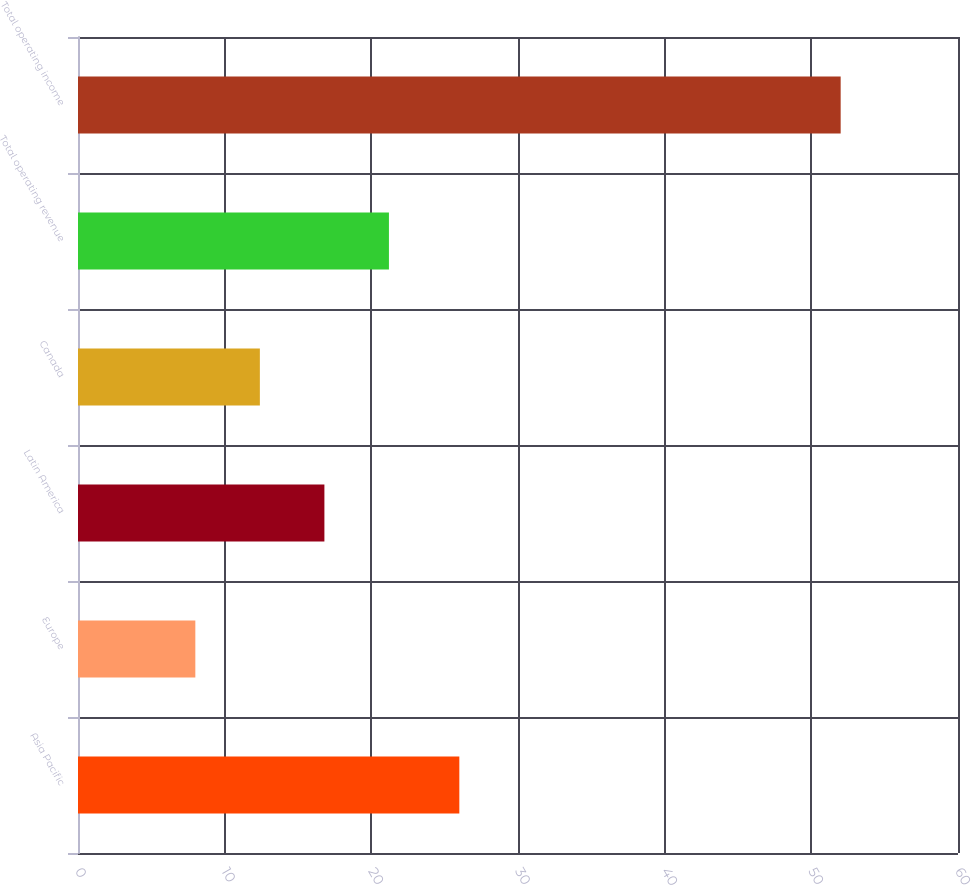Convert chart to OTSL. <chart><loc_0><loc_0><loc_500><loc_500><bar_chart><fcel>Asia Pacific<fcel>Europe<fcel>Latin America<fcel>Canada<fcel>Total operating revenue<fcel>Total operating income<nl><fcel>26<fcel>8<fcel>16.8<fcel>12.4<fcel>21.2<fcel>52<nl></chart> 